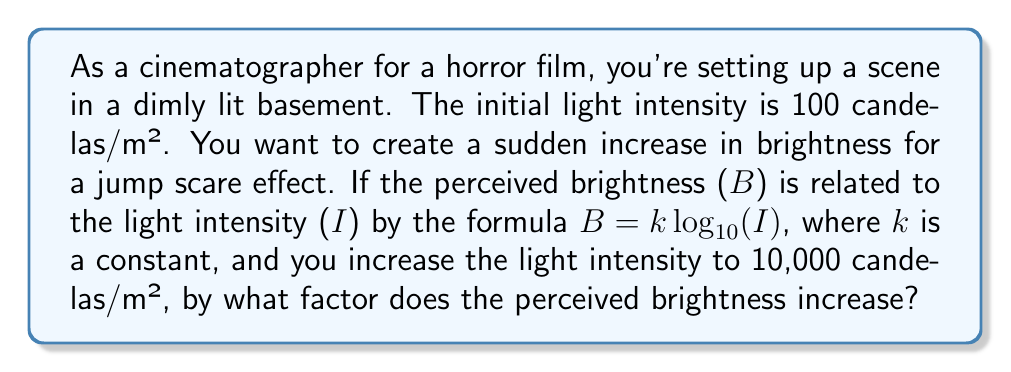Show me your answer to this math problem. Let's approach this step-by-step:

1) We're given that $B = k \log_{10}(I)$, where B is perceived brightness, I is light intensity, and k is a constant.

2) We have two light intensities:
   $I_1 = 100$ candelas/m² (initial)
   $I_2 = 10,000$ candelas/m² (final)

3) Let's call the initial perceived brightness $B_1$ and the final perceived brightness $B_2$:

   $B_1 = k \log_{10}(100)$
   $B_2 = k \log_{10}(10,000)$

4) To find the factor of increase, we need to divide $B_2$ by $B_1$:

   $\frac{B_2}{B_1} = \frac{k \log_{10}(10,000)}{k \log_{10}(100)}$

5) The k's cancel out:

   $\frac{B_2}{B_1} = \frac{\log_{10}(10,000)}{\log_{10}(100)}$

6) Now, let's simplify:
   $\log_{10}(10,000) = \log_{10}(10^4) = 4$
   $\log_{10}(100) = \log_{10}(10^2) = 2$

7) Therefore:

   $\frac{B_2}{B_1} = \frac{4}{2} = 2$

This means the perceived brightness increases by a factor of 2.
Answer: The perceived brightness increases by a factor of 2. 